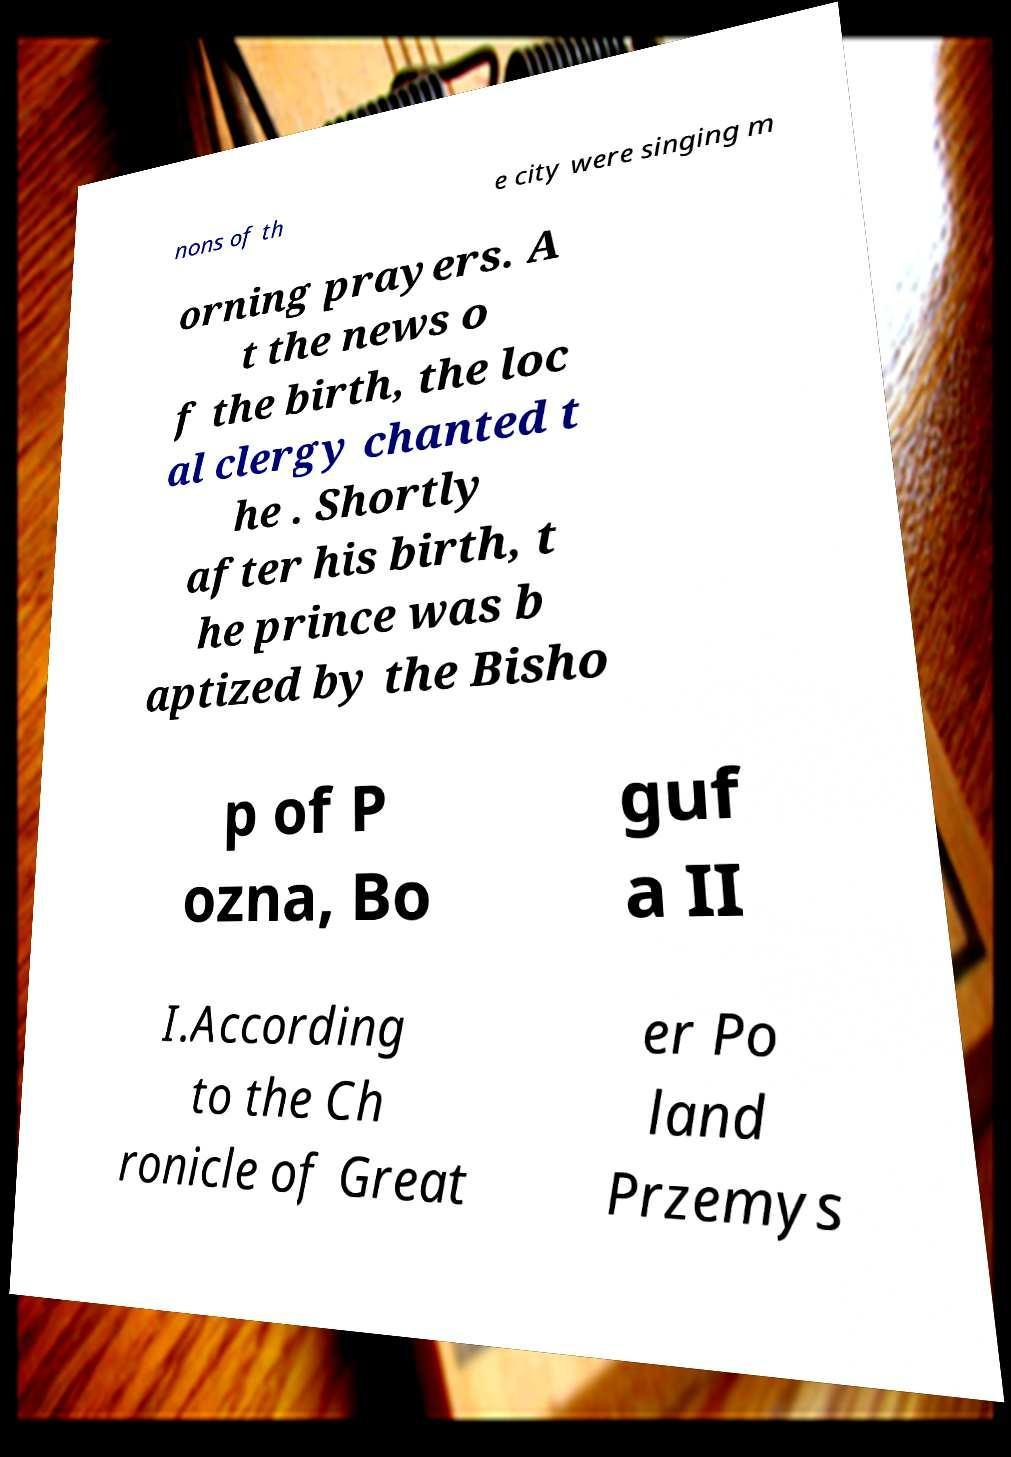Please read and relay the text visible in this image. What does it say? nons of th e city were singing m orning prayers. A t the news o f the birth, the loc al clergy chanted t he . Shortly after his birth, t he prince was b aptized by the Bisho p of P ozna, Bo guf a II I.According to the Ch ronicle of Great er Po land Przemys 